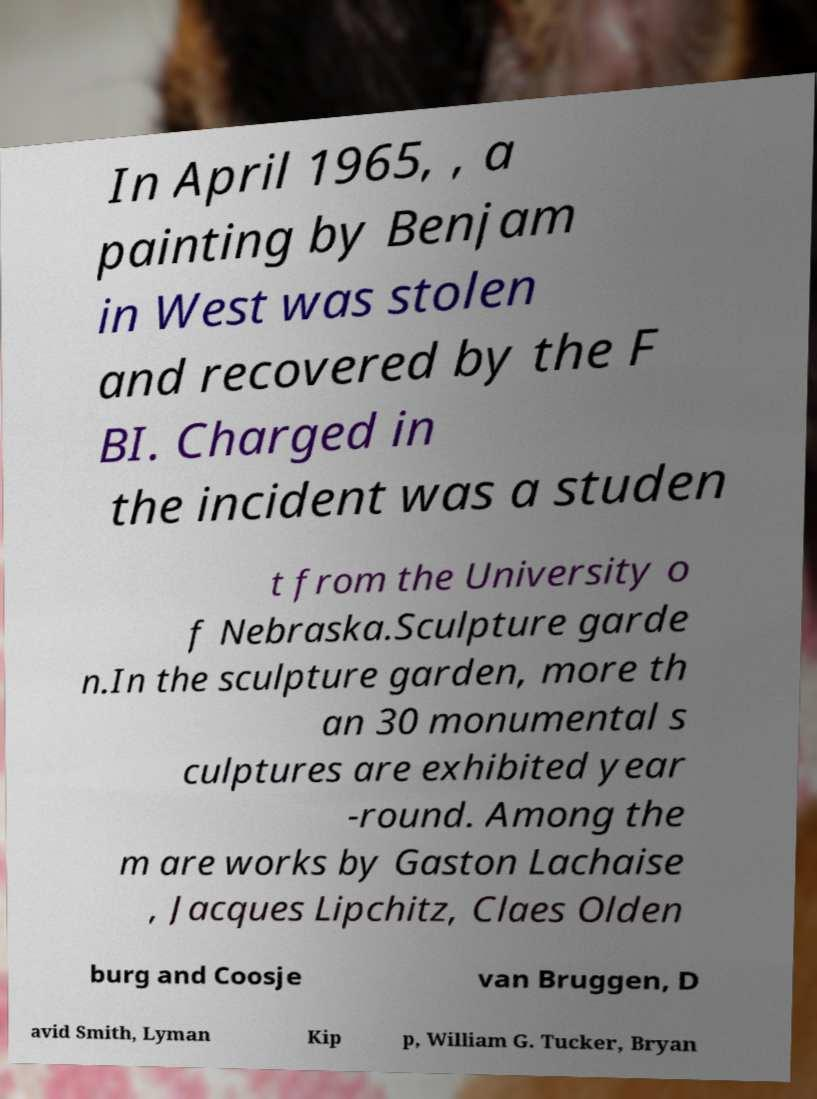Please read and relay the text visible in this image. What does it say? In April 1965, , a painting by Benjam in West was stolen and recovered by the F BI. Charged in the incident was a studen t from the University o f Nebraska.Sculpture garde n.In the sculpture garden, more th an 30 monumental s culptures are exhibited year -round. Among the m are works by Gaston Lachaise , Jacques Lipchitz, Claes Olden burg and Coosje van Bruggen, D avid Smith, Lyman Kip p, William G. Tucker, Bryan 